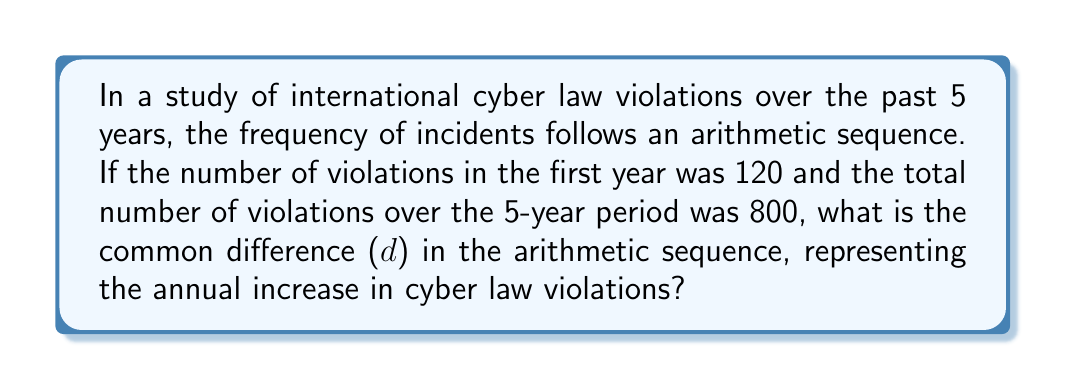Provide a solution to this math problem. Let's approach this step-by-step:

1) In an arithmetic sequence, each term differs from the previous term by a constant amount, d.

2) Let's denote the first term as $a_1 = 120$ (the number of violations in the first year).

3) The arithmetic sequence for the 5 years would be:
   $a_1, a_1 + d, a_1 + 2d, a_1 + 3d, a_1 + 4d$

4) The sum of an arithmetic sequence is given by the formula:
   $S_n = \frac{n}{2}(a_1 + a_n)$, where $n$ is the number of terms

5) We know that $S_5 = 800$ and $a_1 = 120$. We need to find $a_5$.

6) $a_5 = a_1 + 4d$ (because it's the 5th term)

7) Substituting into the sum formula:
   $800 = \frac{5}{2}(120 + (120 + 4d))$

8) Simplifying:
   $800 = \frac{5}{2}(240 + 4d)$
   $800 = 600 + 10d$

9) Solving for d:
   $200 = 10d$
   $d = 20$

Therefore, the common difference in the arithmetic sequence is 20.
Answer: 20 